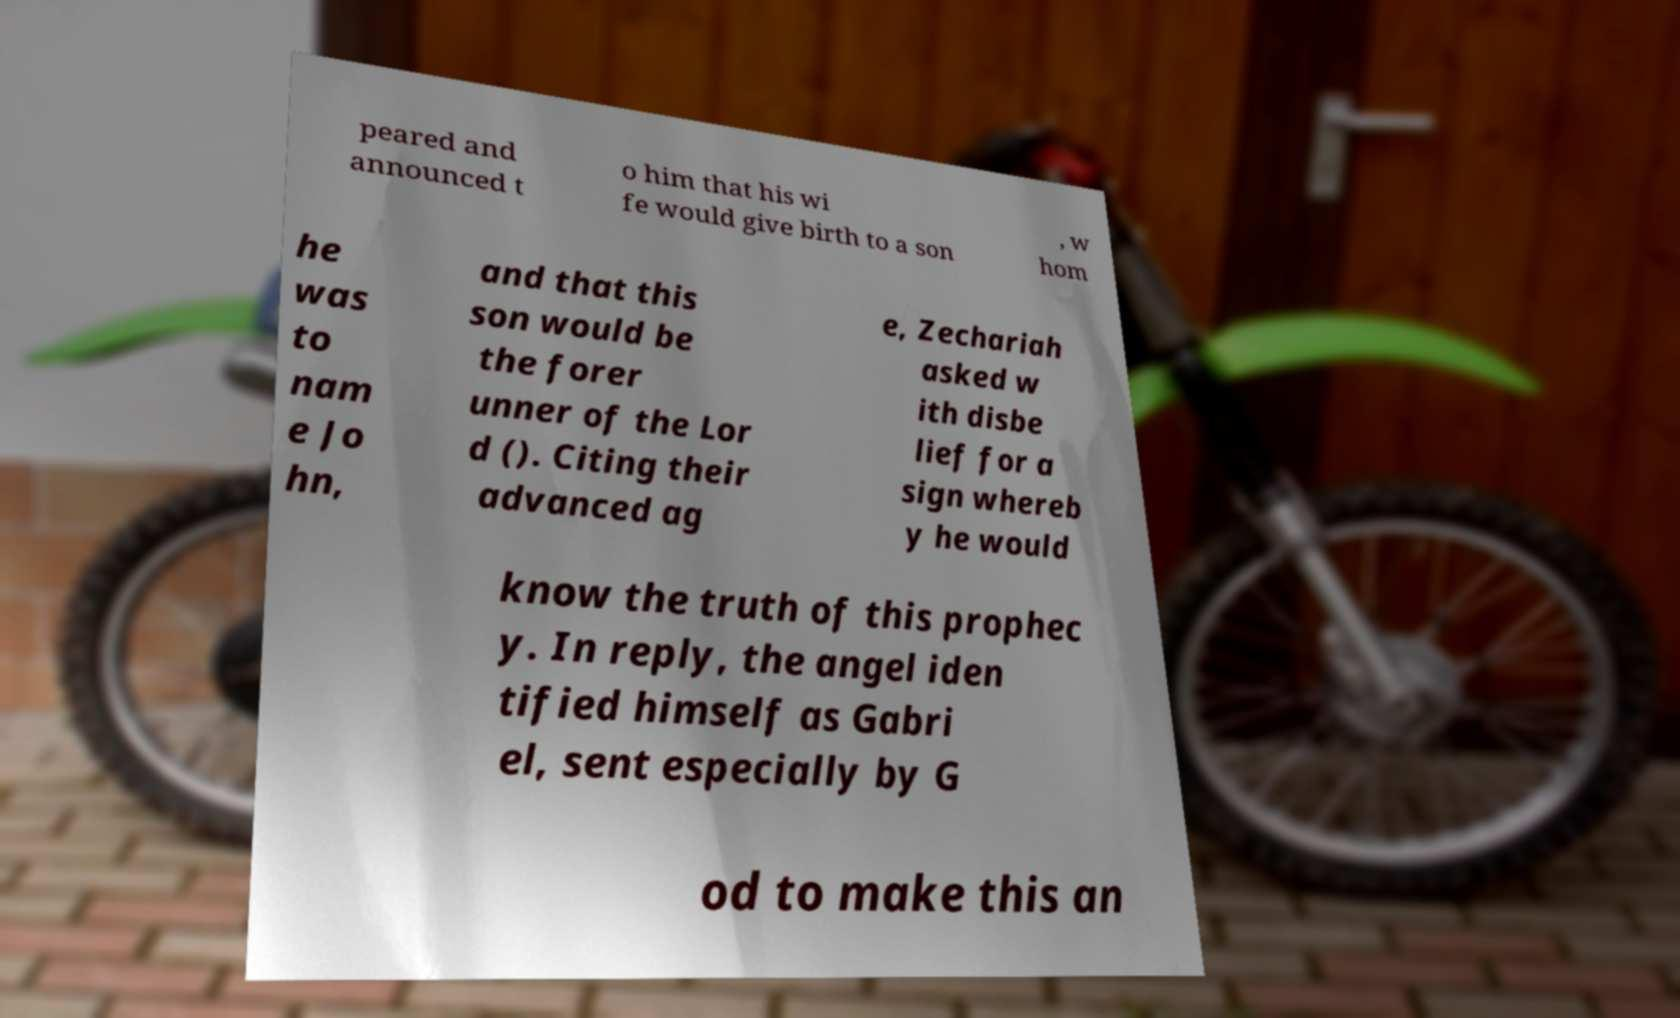I need the written content from this picture converted into text. Can you do that? peared and announced t o him that his wi fe would give birth to a son , w hom he was to nam e Jo hn, and that this son would be the forer unner of the Lor d (). Citing their advanced ag e, Zechariah asked w ith disbe lief for a sign whereb y he would know the truth of this prophec y. In reply, the angel iden tified himself as Gabri el, sent especially by G od to make this an 